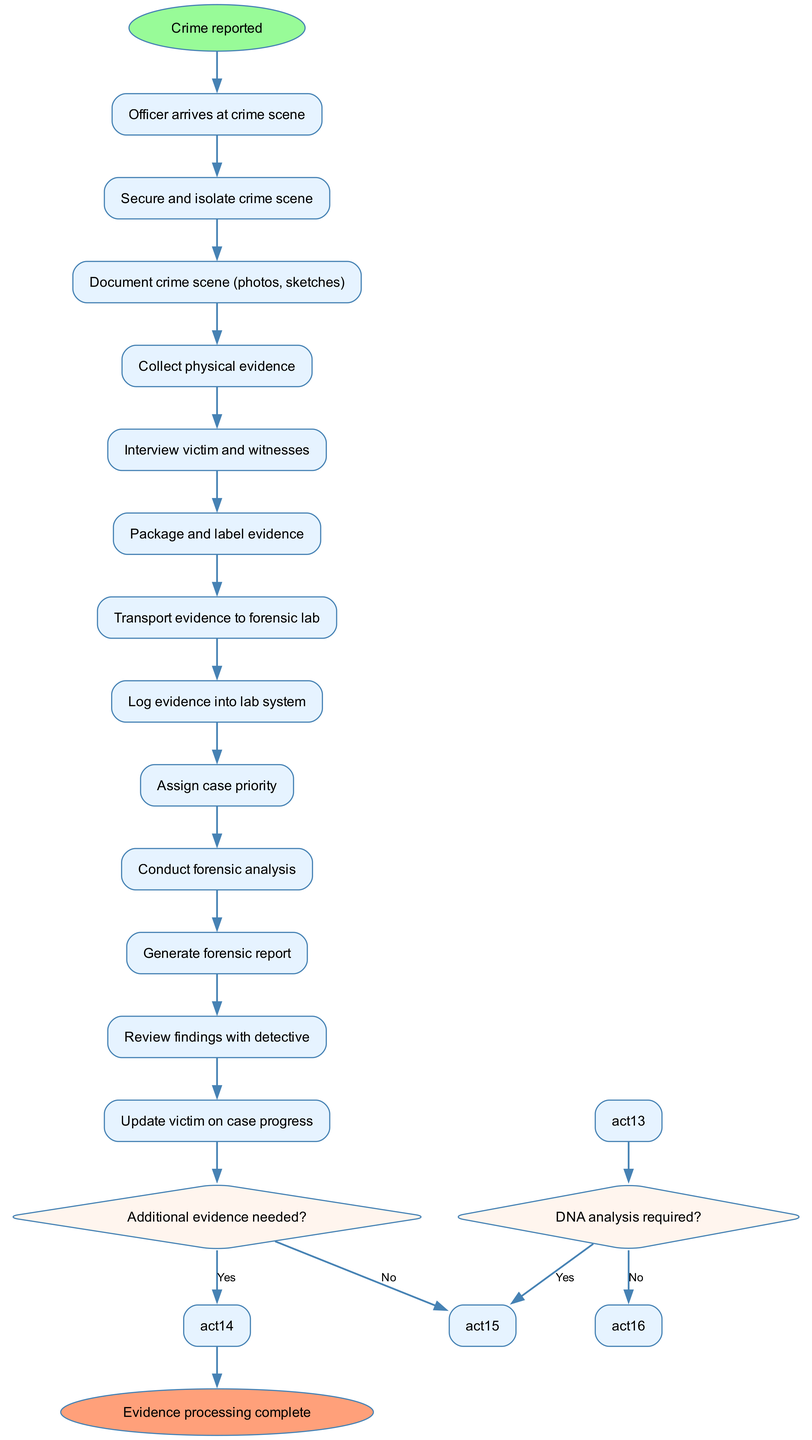What is the first activity in the diagram? The diagram starts with the node labeled "Crime reported." This is the initial step in the evidence collection process.
Answer: Crime reported How many activities are there in total? By counting each unique activity node listed in the diagram, we see there are a total of 12 activities, from "Officer arrives at crime scene" to "Update victim on case progress."
Answer: 12 What decision follows the activity of logging evidence into the lab system? After the "Log evidence into lab system" activity, the next decision point is "Additional evidence needed?" indicating a potential branching of the investigation process.
Answer: Additional evidence needed? What happens if the answer is 'Yes' to the question about additional evidence needed? If the answer is 'Yes', the process returns to the activity "Return to crime scene," indicating that investigators need to gather more information or evidence at the original location.
Answer: Return to crime scene How many decision nodes are present in the diagram? There are 2 decision nodes in the diagram, which correspond to the questions: "Additional evidence needed?" and "DNA analysis required?"
Answer: 2 What is the last activity before the evidence processing is complete? The final activity before reaching the end of the diagram, which states "Evidence processing complete," is "Review findings with detective," indicating the last step of analysis before closure.
Answer: Review findings with detective If DNA analysis is not required, what is the next step after forensic analysis? If DNA analysis is not needed, the next activity step after "Conduct forensic analysis" is "Proceed with other tests," showing alternative methods of investigation.
Answer: Proceed with other tests Which activity involves updating the victim? The activity that includes updating the victim is labeled "Update victim on case progress," indicating the importance of keeping the victim informed throughout the investigation.
Answer: Update victim on case progress What color are the decision nodes in the diagram? The decision nodes are colored with a fill color of '#FFF5EE', distinguishing them from the activity nodes and making them visually identifiable within the diagram.
Answer: '#FFF5EE' 